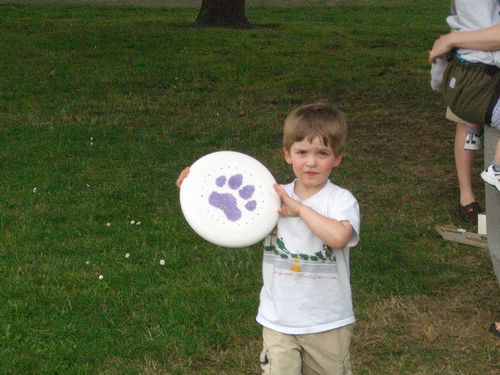<image>What is the name of the type of clothing the boy is wearing on his bottom half? I don't know the exact name of the clothing the boy is wearing. However, it could be described as shorts or pants. What animal is on the frisbee? I don't know what animal is on the frisbee. It may be a dog or a tiger print. What is the name of the type of clothing the boy is wearing on his bottom half? I don't know what is the name of the type of clothing the boy is wearing on his bottom half. It could be shorts, pants or something unknown. What animal is on the frisbee? I am not sure what animal is on the frisbee. It can be seen as a dog, or a wolf. 